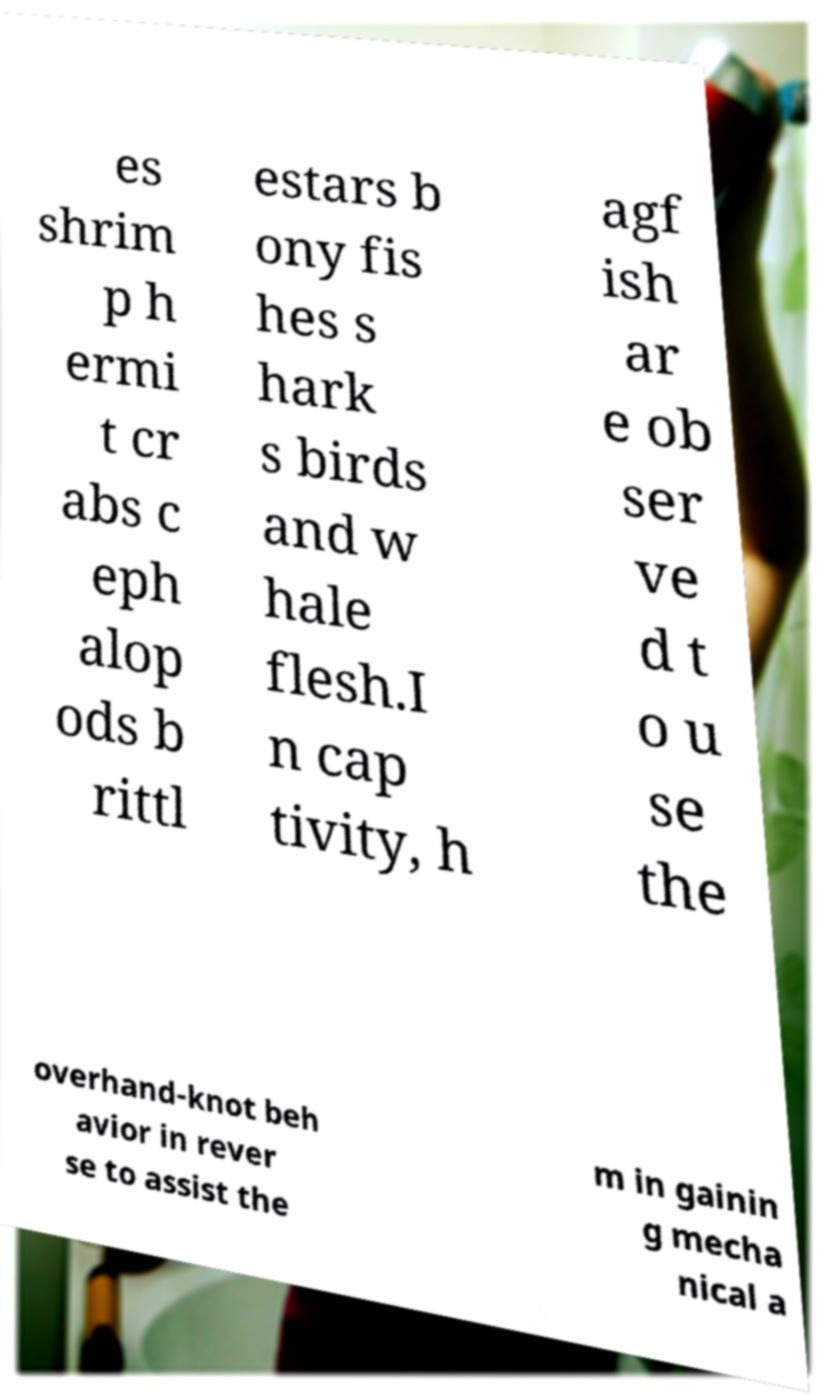Please identify and transcribe the text found in this image. es shrim p h ermi t cr abs c eph alop ods b rittl estars b ony fis hes s hark s birds and w hale flesh.I n cap tivity, h agf ish ar e ob ser ve d t o u se the overhand-knot beh avior in rever se to assist the m in gainin g mecha nical a 